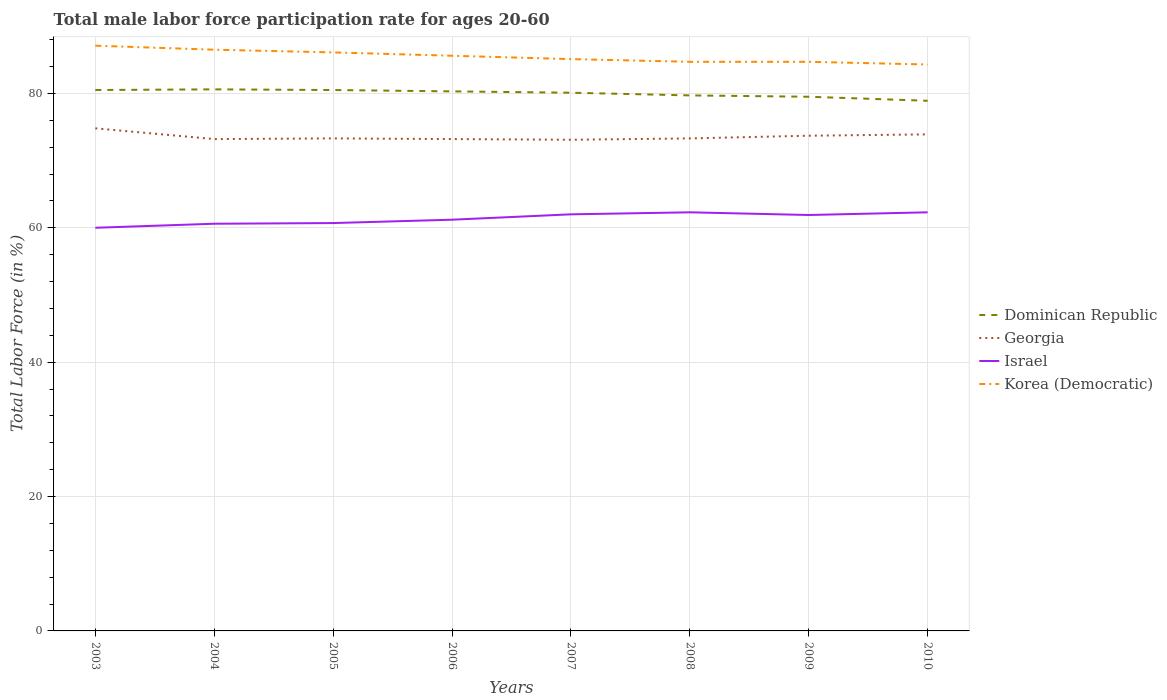Does the line corresponding to Georgia intersect with the line corresponding to Korea (Democratic)?
Offer a very short reply. No. Across all years, what is the maximum male labor force participation rate in Korea (Democratic)?
Provide a succinct answer. 84.3. In which year was the male labor force participation rate in Georgia maximum?
Keep it short and to the point. 2007. What is the difference between the highest and the second highest male labor force participation rate in Israel?
Your response must be concise. 2.3. Is the male labor force participation rate in Georgia strictly greater than the male labor force participation rate in Israel over the years?
Keep it short and to the point. No. What is the difference between two consecutive major ticks on the Y-axis?
Provide a succinct answer. 20. Does the graph contain grids?
Offer a terse response. Yes. How many legend labels are there?
Offer a terse response. 4. How are the legend labels stacked?
Make the answer very short. Vertical. What is the title of the graph?
Offer a terse response. Total male labor force participation rate for ages 20-60. Does "Northern Mariana Islands" appear as one of the legend labels in the graph?
Give a very brief answer. No. What is the label or title of the X-axis?
Offer a very short reply. Years. What is the label or title of the Y-axis?
Provide a succinct answer. Total Labor Force (in %). What is the Total Labor Force (in %) of Dominican Republic in 2003?
Ensure brevity in your answer.  80.5. What is the Total Labor Force (in %) of Georgia in 2003?
Your answer should be compact. 74.8. What is the Total Labor Force (in %) in Israel in 2003?
Offer a very short reply. 60. What is the Total Labor Force (in %) of Korea (Democratic) in 2003?
Offer a very short reply. 87.1. What is the Total Labor Force (in %) in Dominican Republic in 2004?
Ensure brevity in your answer.  80.6. What is the Total Labor Force (in %) in Georgia in 2004?
Make the answer very short. 73.2. What is the Total Labor Force (in %) in Israel in 2004?
Your answer should be very brief. 60.6. What is the Total Labor Force (in %) in Korea (Democratic) in 2004?
Keep it short and to the point. 86.5. What is the Total Labor Force (in %) of Dominican Republic in 2005?
Give a very brief answer. 80.5. What is the Total Labor Force (in %) in Georgia in 2005?
Give a very brief answer. 73.3. What is the Total Labor Force (in %) of Israel in 2005?
Provide a succinct answer. 60.7. What is the Total Labor Force (in %) of Korea (Democratic) in 2005?
Keep it short and to the point. 86.1. What is the Total Labor Force (in %) in Dominican Republic in 2006?
Keep it short and to the point. 80.3. What is the Total Labor Force (in %) in Georgia in 2006?
Your response must be concise. 73.2. What is the Total Labor Force (in %) in Israel in 2006?
Make the answer very short. 61.2. What is the Total Labor Force (in %) of Korea (Democratic) in 2006?
Your answer should be compact. 85.6. What is the Total Labor Force (in %) in Dominican Republic in 2007?
Keep it short and to the point. 80.1. What is the Total Labor Force (in %) of Georgia in 2007?
Offer a very short reply. 73.1. What is the Total Labor Force (in %) of Israel in 2007?
Your answer should be compact. 62. What is the Total Labor Force (in %) of Korea (Democratic) in 2007?
Your answer should be compact. 85.1. What is the Total Labor Force (in %) of Dominican Republic in 2008?
Make the answer very short. 79.7. What is the Total Labor Force (in %) of Georgia in 2008?
Offer a very short reply. 73.3. What is the Total Labor Force (in %) in Israel in 2008?
Your answer should be very brief. 62.3. What is the Total Labor Force (in %) of Korea (Democratic) in 2008?
Ensure brevity in your answer.  84.7. What is the Total Labor Force (in %) of Dominican Republic in 2009?
Your answer should be compact. 79.5. What is the Total Labor Force (in %) of Georgia in 2009?
Your answer should be compact. 73.7. What is the Total Labor Force (in %) in Israel in 2009?
Your answer should be compact. 61.9. What is the Total Labor Force (in %) of Korea (Democratic) in 2009?
Your answer should be very brief. 84.7. What is the Total Labor Force (in %) in Dominican Republic in 2010?
Keep it short and to the point. 78.9. What is the Total Labor Force (in %) of Georgia in 2010?
Offer a terse response. 73.9. What is the Total Labor Force (in %) in Israel in 2010?
Provide a short and direct response. 62.3. What is the Total Labor Force (in %) of Korea (Democratic) in 2010?
Provide a short and direct response. 84.3. Across all years, what is the maximum Total Labor Force (in %) of Dominican Republic?
Make the answer very short. 80.6. Across all years, what is the maximum Total Labor Force (in %) in Georgia?
Offer a very short reply. 74.8. Across all years, what is the maximum Total Labor Force (in %) of Israel?
Your response must be concise. 62.3. Across all years, what is the maximum Total Labor Force (in %) of Korea (Democratic)?
Ensure brevity in your answer.  87.1. Across all years, what is the minimum Total Labor Force (in %) of Dominican Republic?
Ensure brevity in your answer.  78.9. Across all years, what is the minimum Total Labor Force (in %) of Georgia?
Give a very brief answer. 73.1. Across all years, what is the minimum Total Labor Force (in %) in Korea (Democratic)?
Your response must be concise. 84.3. What is the total Total Labor Force (in %) of Dominican Republic in the graph?
Provide a short and direct response. 640.1. What is the total Total Labor Force (in %) of Georgia in the graph?
Give a very brief answer. 588.5. What is the total Total Labor Force (in %) in Israel in the graph?
Make the answer very short. 491. What is the total Total Labor Force (in %) in Korea (Democratic) in the graph?
Your answer should be compact. 684.1. What is the difference between the Total Labor Force (in %) of Dominican Republic in 2003 and that in 2005?
Your answer should be very brief. 0. What is the difference between the Total Labor Force (in %) of Georgia in 2003 and that in 2006?
Offer a terse response. 1.6. What is the difference between the Total Labor Force (in %) in Israel in 2003 and that in 2006?
Offer a terse response. -1.2. What is the difference between the Total Labor Force (in %) of Korea (Democratic) in 2003 and that in 2006?
Ensure brevity in your answer.  1.5. What is the difference between the Total Labor Force (in %) of Dominican Republic in 2003 and that in 2007?
Give a very brief answer. 0.4. What is the difference between the Total Labor Force (in %) in Israel in 2003 and that in 2007?
Your answer should be very brief. -2. What is the difference between the Total Labor Force (in %) of Dominican Republic in 2003 and that in 2008?
Keep it short and to the point. 0.8. What is the difference between the Total Labor Force (in %) of Korea (Democratic) in 2003 and that in 2008?
Offer a very short reply. 2.4. What is the difference between the Total Labor Force (in %) of Dominican Republic in 2003 and that in 2009?
Ensure brevity in your answer.  1. What is the difference between the Total Labor Force (in %) in Dominican Republic in 2003 and that in 2010?
Offer a terse response. 1.6. What is the difference between the Total Labor Force (in %) in Georgia in 2003 and that in 2010?
Your answer should be compact. 0.9. What is the difference between the Total Labor Force (in %) of Israel in 2003 and that in 2010?
Provide a succinct answer. -2.3. What is the difference between the Total Labor Force (in %) in Dominican Republic in 2004 and that in 2005?
Keep it short and to the point. 0.1. What is the difference between the Total Labor Force (in %) in Georgia in 2004 and that in 2005?
Make the answer very short. -0.1. What is the difference between the Total Labor Force (in %) in Dominican Republic in 2004 and that in 2006?
Your answer should be compact. 0.3. What is the difference between the Total Labor Force (in %) in Korea (Democratic) in 2004 and that in 2008?
Give a very brief answer. 1.8. What is the difference between the Total Labor Force (in %) of Georgia in 2004 and that in 2009?
Your response must be concise. -0.5. What is the difference between the Total Labor Force (in %) of Israel in 2004 and that in 2009?
Your answer should be compact. -1.3. What is the difference between the Total Labor Force (in %) in Korea (Democratic) in 2004 and that in 2009?
Give a very brief answer. 1.8. What is the difference between the Total Labor Force (in %) in Dominican Republic in 2004 and that in 2010?
Ensure brevity in your answer.  1.7. What is the difference between the Total Labor Force (in %) of Korea (Democratic) in 2004 and that in 2010?
Ensure brevity in your answer.  2.2. What is the difference between the Total Labor Force (in %) of Dominican Republic in 2005 and that in 2006?
Your answer should be compact. 0.2. What is the difference between the Total Labor Force (in %) in Georgia in 2005 and that in 2006?
Provide a succinct answer. 0.1. What is the difference between the Total Labor Force (in %) of Israel in 2005 and that in 2006?
Provide a succinct answer. -0.5. What is the difference between the Total Labor Force (in %) in Korea (Democratic) in 2005 and that in 2006?
Provide a short and direct response. 0.5. What is the difference between the Total Labor Force (in %) of Dominican Republic in 2005 and that in 2007?
Your answer should be compact. 0.4. What is the difference between the Total Labor Force (in %) of Georgia in 2005 and that in 2007?
Your answer should be compact. 0.2. What is the difference between the Total Labor Force (in %) of Georgia in 2005 and that in 2008?
Provide a short and direct response. 0. What is the difference between the Total Labor Force (in %) of Korea (Democratic) in 2005 and that in 2008?
Provide a short and direct response. 1.4. What is the difference between the Total Labor Force (in %) in Dominican Republic in 2005 and that in 2009?
Ensure brevity in your answer.  1. What is the difference between the Total Labor Force (in %) in Korea (Democratic) in 2005 and that in 2009?
Keep it short and to the point. 1.4. What is the difference between the Total Labor Force (in %) in Dominican Republic in 2005 and that in 2010?
Provide a short and direct response. 1.6. What is the difference between the Total Labor Force (in %) of Georgia in 2006 and that in 2007?
Give a very brief answer. 0.1. What is the difference between the Total Labor Force (in %) in Israel in 2006 and that in 2007?
Your answer should be very brief. -0.8. What is the difference between the Total Labor Force (in %) of Korea (Democratic) in 2006 and that in 2008?
Give a very brief answer. 0.9. What is the difference between the Total Labor Force (in %) of Dominican Republic in 2006 and that in 2009?
Ensure brevity in your answer.  0.8. What is the difference between the Total Labor Force (in %) in Israel in 2006 and that in 2009?
Your answer should be compact. -0.7. What is the difference between the Total Labor Force (in %) of Korea (Democratic) in 2006 and that in 2009?
Offer a terse response. 0.9. What is the difference between the Total Labor Force (in %) of Dominican Republic in 2006 and that in 2010?
Make the answer very short. 1.4. What is the difference between the Total Labor Force (in %) in Israel in 2006 and that in 2010?
Your response must be concise. -1.1. What is the difference between the Total Labor Force (in %) of Korea (Democratic) in 2006 and that in 2010?
Your response must be concise. 1.3. What is the difference between the Total Labor Force (in %) of Dominican Republic in 2007 and that in 2008?
Offer a very short reply. 0.4. What is the difference between the Total Labor Force (in %) of Georgia in 2007 and that in 2008?
Your response must be concise. -0.2. What is the difference between the Total Labor Force (in %) in Israel in 2007 and that in 2008?
Give a very brief answer. -0.3. What is the difference between the Total Labor Force (in %) of Israel in 2007 and that in 2009?
Your response must be concise. 0.1. What is the difference between the Total Labor Force (in %) in Korea (Democratic) in 2007 and that in 2009?
Your response must be concise. 0.4. What is the difference between the Total Labor Force (in %) in Dominican Republic in 2007 and that in 2010?
Offer a very short reply. 1.2. What is the difference between the Total Labor Force (in %) in Georgia in 2007 and that in 2010?
Your answer should be very brief. -0.8. What is the difference between the Total Labor Force (in %) of Dominican Republic in 2008 and that in 2009?
Ensure brevity in your answer.  0.2. What is the difference between the Total Labor Force (in %) of Israel in 2008 and that in 2009?
Your answer should be very brief. 0.4. What is the difference between the Total Labor Force (in %) of Korea (Democratic) in 2008 and that in 2009?
Your answer should be compact. 0. What is the difference between the Total Labor Force (in %) of Israel in 2008 and that in 2010?
Your answer should be very brief. 0. What is the difference between the Total Labor Force (in %) in Israel in 2009 and that in 2010?
Give a very brief answer. -0.4. What is the difference between the Total Labor Force (in %) in Korea (Democratic) in 2009 and that in 2010?
Your answer should be very brief. 0.4. What is the difference between the Total Labor Force (in %) in Georgia in 2003 and the Total Labor Force (in %) in Israel in 2004?
Keep it short and to the point. 14.2. What is the difference between the Total Labor Force (in %) in Georgia in 2003 and the Total Labor Force (in %) in Korea (Democratic) in 2004?
Give a very brief answer. -11.7. What is the difference between the Total Labor Force (in %) of Israel in 2003 and the Total Labor Force (in %) of Korea (Democratic) in 2004?
Your answer should be very brief. -26.5. What is the difference between the Total Labor Force (in %) of Dominican Republic in 2003 and the Total Labor Force (in %) of Georgia in 2005?
Ensure brevity in your answer.  7.2. What is the difference between the Total Labor Force (in %) in Dominican Republic in 2003 and the Total Labor Force (in %) in Israel in 2005?
Keep it short and to the point. 19.8. What is the difference between the Total Labor Force (in %) of Dominican Republic in 2003 and the Total Labor Force (in %) of Korea (Democratic) in 2005?
Ensure brevity in your answer.  -5.6. What is the difference between the Total Labor Force (in %) in Georgia in 2003 and the Total Labor Force (in %) in Korea (Democratic) in 2005?
Ensure brevity in your answer.  -11.3. What is the difference between the Total Labor Force (in %) of Israel in 2003 and the Total Labor Force (in %) of Korea (Democratic) in 2005?
Provide a succinct answer. -26.1. What is the difference between the Total Labor Force (in %) of Dominican Republic in 2003 and the Total Labor Force (in %) of Georgia in 2006?
Keep it short and to the point. 7.3. What is the difference between the Total Labor Force (in %) of Dominican Republic in 2003 and the Total Labor Force (in %) of Israel in 2006?
Offer a very short reply. 19.3. What is the difference between the Total Labor Force (in %) in Israel in 2003 and the Total Labor Force (in %) in Korea (Democratic) in 2006?
Your response must be concise. -25.6. What is the difference between the Total Labor Force (in %) of Dominican Republic in 2003 and the Total Labor Force (in %) of Israel in 2007?
Offer a very short reply. 18.5. What is the difference between the Total Labor Force (in %) in Georgia in 2003 and the Total Labor Force (in %) in Israel in 2007?
Your response must be concise. 12.8. What is the difference between the Total Labor Force (in %) in Georgia in 2003 and the Total Labor Force (in %) in Korea (Democratic) in 2007?
Ensure brevity in your answer.  -10.3. What is the difference between the Total Labor Force (in %) in Israel in 2003 and the Total Labor Force (in %) in Korea (Democratic) in 2007?
Ensure brevity in your answer.  -25.1. What is the difference between the Total Labor Force (in %) in Dominican Republic in 2003 and the Total Labor Force (in %) in Israel in 2008?
Your answer should be very brief. 18.2. What is the difference between the Total Labor Force (in %) in Dominican Republic in 2003 and the Total Labor Force (in %) in Korea (Democratic) in 2008?
Give a very brief answer. -4.2. What is the difference between the Total Labor Force (in %) in Israel in 2003 and the Total Labor Force (in %) in Korea (Democratic) in 2008?
Your response must be concise. -24.7. What is the difference between the Total Labor Force (in %) in Dominican Republic in 2003 and the Total Labor Force (in %) in Korea (Democratic) in 2009?
Offer a terse response. -4.2. What is the difference between the Total Labor Force (in %) of Israel in 2003 and the Total Labor Force (in %) of Korea (Democratic) in 2009?
Provide a succinct answer. -24.7. What is the difference between the Total Labor Force (in %) of Dominican Republic in 2003 and the Total Labor Force (in %) of Israel in 2010?
Provide a succinct answer. 18.2. What is the difference between the Total Labor Force (in %) of Dominican Republic in 2003 and the Total Labor Force (in %) of Korea (Democratic) in 2010?
Provide a short and direct response. -3.8. What is the difference between the Total Labor Force (in %) of Georgia in 2003 and the Total Labor Force (in %) of Israel in 2010?
Keep it short and to the point. 12.5. What is the difference between the Total Labor Force (in %) of Georgia in 2003 and the Total Labor Force (in %) of Korea (Democratic) in 2010?
Ensure brevity in your answer.  -9.5. What is the difference between the Total Labor Force (in %) in Israel in 2003 and the Total Labor Force (in %) in Korea (Democratic) in 2010?
Keep it short and to the point. -24.3. What is the difference between the Total Labor Force (in %) in Georgia in 2004 and the Total Labor Force (in %) in Israel in 2005?
Make the answer very short. 12.5. What is the difference between the Total Labor Force (in %) of Israel in 2004 and the Total Labor Force (in %) of Korea (Democratic) in 2005?
Your answer should be compact. -25.5. What is the difference between the Total Labor Force (in %) in Dominican Republic in 2004 and the Total Labor Force (in %) in Israel in 2006?
Your answer should be very brief. 19.4. What is the difference between the Total Labor Force (in %) in Dominican Republic in 2004 and the Total Labor Force (in %) in Korea (Democratic) in 2006?
Provide a short and direct response. -5. What is the difference between the Total Labor Force (in %) of Georgia in 2004 and the Total Labor Force (in %) of Israel in 2006?
Keep it short and to the point. 12. What is the difference between the Total Labor Force (in %) in Georgia in 2004 and the Total Labor Force (in %) in Korea (Democratic) in 2007?
Provide a short and direct response. -11.9. What is the difference between the Total Labor Force (in %) in Israel in 2004 and the Total Labor Force (in %) in Korea (Democratic) in 2007?
Your answer should be compact. -24.5. What is the difference between the Total Labor Force (in %) in Dominican Republic in 2004 and the Total Labor Force (in %) in Israel in 2008?
Provide a succinct answer. 18.3. What is the difference between the Total Labor Force (in %) of Dominican Republic in 2004 and the Total Labor Force (in %) of Korea (Democratic) in 2008?
Provide a short and direct response. -4.1. What is the difference between the Total Labor Force (in %) of Georgia in 2004 and the Total Labor Force (in %) of Israel in 2008?
Offer a very short reply. 10.9. What is the difference between the Total Labor Force (in %) of Georgia in 2004 and the Total Labor Force (in %) of Korea (Democratic) in 2008?
Your answer should be very brief. -11.5. What is the difference between the Total Labor Force (in %) of Israel in 2004 and the Total Labor Force (in %) of Korea (Democratic) in 2008?
Your answer should be compact. -24.1. What is the difference between the Total Labor Force (in %) of Georgia in 2004 and the Total Labor Force (in %) of Korea (Democratic) in 2009?
Offer a very short reply. -11.5. What is the difference between the Total Labor Force (in %) in Israel in 2004 and the Total Labor Force (in %) in Korea (Democratic) in 2009?
Provide a short and direct response. -24.1. What is the difference between the Total Labor Force (in %) of Dominican Republic in 2004 and the Total Labor Force (in %) of Israel in 2010?
Keep it short and to the point. 18.3. What is the difference between the Total Labor Force (in %) of Dominican Republic in 2004 and the Total Labor Force (in %) of Korea (Democratic) in 2010?
Provide a short and direct response. -3.7. What is the difference between the Total Labor Force (in %) of Georgia in 2004 and the Total Labor Force (in %) of Korea (Democratic) in 2010?
Your response must be concise. -11.1. What is the difference between the Total Labor Force (in %) of Israel in 2004 and the Total Labor Force (in %) of Korea (Democratic) in 2010?
Offer a terse response. -23.7. What is the difference between the Total Labor Force (in %) in Dominican Republic in 2005 and the Total Labor Force (in %) in Georgia in 2006?
Ensure brevity in your answer.  7.3. What is the difference between the Total Labor Force (in %) in Dominican Republic in 2005 and the Total Labor Force (in %) in Israel in 2006?
Provide a short and direct response. 19.3. What is the difference between the Total Labor Force (in %) of Dominican Republic in 2005 and the Total Labor Force (in %) of Korea (Democratic) in 2006?
Your answer should be very brief. -5.1. What is the difference between the Total Labor Force (in %) of Georgia in 2005 and the Total Labor Force (in %) of Israel in 2006?
Ensure brevity in your answer.  12.1. What is the difference between the Total Labor Force (in %) of Georgia in 2005 and the Total Labor Force (in %) of Korea (Democratic) in 2006?
Your answer should be compact. -12.3. What is the difference between the Total Labor Force (in %) in Israel in 2005 and the Total Labor Force (in %) in Korea (Democratic) in 2006?
Give a very brief answer. -24.9. What is the difference between the Total Labor Force (in %) of Dominican Republic in 2005 and the Total Labor Force (in %) of Israel in 2007?
Your response must be concise. 18.5. What is the difference between the Total Labor Force (in %) of Dominican Republic in 2005 and the Total Labor Force (in %) of Korea (Democratic) in 2007?
Ensure brevity in your answer.  -4.6. What is the difference between the Total Labor Force (in %) of Israel in 2005 and the Total Labor Force (in %) of Korea (Democratic) in 2007?
Provide a succinct answer. -24.4. What is the difference between the Total Labor Force (in %) in Dominican Republic in 2005 and the Total Labor Force (in %) in Georgia in 2008?
Ensure brevity in your answer.  7.2. What is the difference between the Total Labor Force (in %) in Dominican Republic in 2005 and the Total Labor Force (in %) in Korea (Democratic) in 2008?
Provide a short and direct response. -4.2. What is the difference between the Total Labor Force (in %) in Georgia in 2005 and the Total Labor Force (in %) in Korea (Democratic) in 2008?
Provide a succinct answer. -11.4. What is the difference between the Total Labor Force (in %) of Dominican Republic in 2005 and the Total Labor Force (in %) of Georgia in 2009?
Offer a very short reply. 6.8. What is the difference between the Total Labor Force (in %) in Dominican Republic in 2005 and the Total Labor Force (in %) in Korea (Democratic) in 2009?
Give a very brief answer. -4.2. What is the difference between the Total Labor Force (in %) of Georgia in 2005 and the Total Labor Force (in %) of Israel in 2009?
Keep it short and to the point. 11.4. What is the difference between the Total Labor Force (in %) in Israel in 2005 and the Total Labor Force (in %) in Korea (Democratic) in 2009?
Provide a succinct answer. -24. What is the difference between the Total Labor Force (in %) of Dominican Republic in 2005 and the Total Labor Force (in %) of Georgia in 2010?
Your response must be concise. 6.6. What is the difference between the Total Labor Force (in %) of Georgia in 2005 and the Total Labor Force (in %) of Israel in 2010?
Your response must be concise. 11. What is the difference between the Total Labor Force (in %) of Georgia in 2005 and the Total Labor Force (in %) of Korea (Democratic) in 2010?
Your response must be concise. -11. What is the difference between the Total Labor Force (in %) of Israel in 2005 and the Total Labor Force (in %) of Korea (Democratic) in 2010?
Provide a short and direct response. -23.6. What is the difference between the Total Labor Force (in %) of Dominican Republic in 2006 and the Total Labor Force (in %) of Georgia in 2007?
Your answer should be compact. 7.2. What is the difference between the Total Labor Force (in %) in Dominican Republic in 2006 and the Total Labor Force (in %) in Israel in 2007?
Ensure brevity in your answer.  18.3. What is the difference between the Total Labor Force (in %) of Dominican Republic in 2006 and the Total Labor Force (in %) of Korea (Democratic) in 2007?
Provide a short and direct response. -4.8. What is the difference between the Total Labor Force (in %) of Israel in 2006 and the Total Labor Force (in %) of Korea (Democratic) in 2007?
Your answer should be compact. -23.9. What is the difference between the Total Labor Force (in %) in Georgia in 2006 and the Total Labor Force (in %) in Israel in 2008?
Give a very brief answer. 10.9. What is the difference between the Total Labor Force (in %) of Georgia in 2006 and the Total Labor Force (in %) of Korea (Democratic) in 2008?
Give a very brief answer. -11.5. What is the difference between the Total Labor Force (in %) in Israel in 2006 and the Total Labor Force (in %) in Korea (Democratic) in 2008?
Your response must be concise. -23.5. What is the difference between the Total Labor Force (in %) in Georgia in 2006 and the Total Labor Force (in %) in Israel in 2009?
Ensure brevity in your answer.  11.3. What is the difference between the Total Labor Force (in %) in Georgia in 2006 and the Total Labor Force (in %) in Korea (Democratic) in 2009?
Offer a very short reply. -11.5. What is the difference between the Total Labor Force (in %) in Israel in 2006 and the Total Labor Force (in %) in Korea (Democratic) in 2009?
Offer a terse response. -23.5. What is the difference between the Total Labor Force (in %) in Dominican Republic in 2006 and the Total Labor Force (in %) in Israel in 2010?
Offer a very short reply. 18. What is the difference between the Total Labor Force (in %) of Georgia in 2006 and the Total Labor Force (in %) of Israel in 2010?
Provide a short and direct response. 10.9. What is the difference between the Total Labor Force (in %) in Israel in 2006 and the Total Labor Force (in %) in Korea (Democratic) in 2010?
Give a very brief answer. -23.1. What is the difference between the Total Labor Force (in %) of Dominican Republic in 2007 and the Total Labor Force (in %) of Georgia in 2008?
Keep it short and to the point. 6.8. What is the difference between the Total Labor Force (in %) of Dominican Republic in 2007 and the Total Labor Force (in %) of Israel in 2008?
Ensure brevity in your answer.  17.8. What is the difference between the Total Labor Force (in %) in Dominican Republic in 2007 and the Total Labor Force (in %) in Korea (Democratic) in 2008?
Your response must be concise. -4.6. What is the difference between the Total Labor Force (in %) of Georgia in 2007 and the Total Labor Force (in %) of Korea (Democratic) in 2008?
Offer a terse response. -11.6. What is the difference between the Total Labor Force (in %) of Israel in 2007 and the Total Labor Force (in %) of Korea (Democratic) in 2008?
Provide a short and direct response. -22.7. What is the difference between the Total Labor Force (in %) of Dominican Republic in 2007 and the Total Labor Force (in %) of Israel in 2009?
Your answer should be very brief. 18.2. What is the difference between the Total Labor Force (in %) of Dominican Republic in 2007 and the Total Labor Force (in %) of Korea (Democratic) in 2009?
Your answer should be very brief. -4.6. What is the difference between the Total Labor Force (in %) in Georgia in 2007 and the Total Labor Force (in %) in Korea (Democratic) in 2009?
Your response must be concise. -11.6. What is the difference between the Total Labor Force (in %) in Israel in 2007 and the Total Labor Force (in %) in Korea (Democratic) in 2009?
Give a very brief answer. -22.7. What is the difference between the Total Labor Force (in %) of Dominican Republic in 2007 and the Total Labor Force (in %) of Georgia in 2010?
Keep it short and to the point. 6.2. What is the difference between the Total Labor Force (in %) of Dominican Republic in 2007 and the Total Labor Force (in %) of Korea (Democratic) in 2010?
Provide a short and direct response. -4.2. What is the difference between the Total Labor Force (in %) of Israel in 2007 and the Total Labor Force (in %) of Korea (Democratic) in 2010?
Give a very brief answer. -22.3. What is the difference between the Total Labor Force (in %) of Dominican Republic in 2008 and the Total Labor Force (in %) of Georgia in 2009?
Offer a terse response. 6. What is the difference between the Total Labor Force (in %) of Dominican Republic in 2008 and the Total Labor Force (in %) of Israel in 2009?
Provide a short and direct response. 17.8. What is the difference between the Total Labor Force (in %) of Dominican Republic in 2008 and the Total Labor Force (in %) of Korea (Democratic) in 2009?
Offer a very short reply. -5. What is the difference between the Total Labor Force (in %) in Israel in 2008 and the Total Labor Force (in %) in Korea (Democratic) in 2009?
Ensure brevity in your answer.  -22.4. What is the difference between the Total Labor Force (in %) of Dominican Republic in 2008 and the Total Labor Force (in %) of Georgia in 2010?
Your answer should be very brief. 5.8. What is the difference between the Total Labor Force (in %) in Georgia in 2008 and the Total Labor Force (in %) in Israel in 2010?
Offer a terse response. 11. What is the difference between the Total Labor Force (in %) in Israel in 2008 and the Total Labor Force (in %) in Korea (Democratic) in 2010?
Offer a terse response. -22. What is the difference between the Total Labor Force (in %) of Dominican Republic in 2009 and the Total Labor Force (in %) of Georgia in 2010?
Your answer should be compact. 5.6. What is the difference between the Total Labor Force (in %) in Georgia in 2009 and the Total Labor Force (in %) in Israel in 2010?
Your answer should be very brief. 11.4. What is the difference between the Total Labor Force (in %) in Israel in 2009 and the Total Labor Force (in %) in Korea (Democratic) in 2010?
Ensure brevity in your answer.  -22.4. What is the average Total Labor Force (in %) of Dominican Republic per year?
Your answer should be compact. 80.01. What is the average Total Labor Force (in %) of Georgia per year?
Make the answer very short. 73.56. What is the average Total Labor Force (in %) in Israel per year?
Offer a terse response. 61.38. What is the average Total Labor Force (in %) in Korea (Democratic) per year?
Ensure brevity in your answer.  85.51. In the year 2003, what is the difference between the Total Labor Force (in %) of Dominican Republic and Total Labor Force (in %) of Georgia?
Ensure brevity in your answer.  5.7. In the year 2003, what is the difference between the Total Labor Force (in %) in Dominican Republic and Total Labor Force (in %) in Israel?
Keep it short and to the point. 20.5. In the year 2003, what is the difference between the Total Labor Force (in %) of Dominican Republic and Total Labor Force (in %) of Korea (Democratic)?
Your answer should be compact. -6.6. In the year 2003, what is the difference between the Total Labor Force (in %) of Israel and Total Labor Force (in %) of Korea (Democratic)?
Your answer should be very brief. -27.1. In the year 2004, what is the difference between the Total Labor Force (in %) of Dominican Republic and Total Labor Force (in %) of Israel?
Give a very brief answer. 20. In the year 2004, what is the difference between the Total Labor Force (in %) in Dominican Republic and Total Labor Force (in %) in Korea (Democratic)?
Keep it short and to the point. -5.9. In the year 2004, what is the difference between the Total Labor Force (in %) in Israel and Total Labor Force (in %) in Korea (Democratic)?
Provide a succinct answer. -25.9. In the year 2005, what is the difference between the Total Labor Force (in %) in Dominican Republic and Total Labor Force (in %) in Israel?
Ensure brevity in your answer.  19.8. In the year 2005, what is the difference between the Total Labor Force (in %) in Israel and Total Labor Force (in %) in Korea (Democratic)?
Make the answer very short. -25.4. In the year 2006, what is the difference between the Total Labor Force (in %) of Dominican Republic and Total Labor Force (in %) of Georgia?
Ensure brevity in your answer.  7.1. In the year 2006, what is the difference between the Total Labor Force (in %) of Dominican Republic and Total Labor Force (in %) of Israel?
Keep it short and to the point. 19.1. In the year 2006, what is the difference between the Total Labor Force (in %) of Israel and Total Labor Force (in %) of Korea (Democratic)?
Your response must be concise. -24.4. In the year 2007, what is the difference between the Total Labor Force (in %) of Dominican Republic and Total Labor Force (in %) of Israel?
Provide a succinct answer. 18.1. In the year 2007, what is the difference between the Total Labor Force (in %) of Georgia and Total Labor Force (in %) of Israel?
Ensure brevity in your answer.  11.1. In the year 2007, what is the difference between the Total Labor Force (in %) of Israel and Total Labor Force (in %) of Korea (Democratic)?
Make the answer very short. -23.1. In the year 2008, what is the difference between the Total Labor Force (in %) in Dominican Republic and Total Labor Force (in %) in Israel?
Your response must be concise. 17.4. In the year 2008, what is the difference between the Total Labor Force (in %) of Dominican Republic and Total Labor Force (in %) of Korea (Democratic)?
Your response must be concise. -5. In the year 2008, what is the difference between the Total Labor Force (in %) of Georgia and Total Labor Force (in %) of Israel?
Make the answer very short. 11. In the year 2008, what is the difference between the Total Labor Force (in %) of Georgia and Total Labor Force (in %) of Korea (Democratic)?
Provide a short and direct response. -11.4. In the year 2008, what is the difference between the Total Labor Force (in %) of Israel and Total Labor Force (in %) of Korea (Democratic)?
Ensure brevity in your answer.  -22.4. In the year 2009, what is the difference between the Total Labor Force (in %) in Dominican Republic and Total Labor Force (in %) in Georgia?
Your response must be concise. 5.8. In the year 2009, what is the difference between the Total Labor Force (in %) of Dominican Republic and Total Labor Force (in %) of Israel?
Provide a short and direct response. 17.6. In the year 2009, what is the difference between the Total Labor Force (in %) in Dominican Republic and Total Labor Force (in %) in Korea (Democratic)?
Provide a short and direct response. -5.2. In the year 2009, what is the difference between the Total Labor Force (in %) of Georgia and Total Labor Force (in %) of Israel?
Offer a terse response. 11.8. In the year 2009, what is the difference between the Total Labor Force (in %) of Georgia and Total Labor Force (in %) of Korea (Democratic)?
Keep it short and to the point. -11. In the year 2009, what is the difference between the Total Labor Force (in %) of Israel and Total Labor Force (in %) of Korea (Democratic)?
Offer a terse response. -22.8. In the year 2010, what is the difference between the Total Labor Force (in %) of Dominican Republic and Total Labor Force (in %) of Israel?
Ensure brevity in your answer.  16.6. What is the ratio of the Total Labor Force (in %) in Dominican Republic in 2003 to that in 2004?
Make the answer very short. 1. What is the ratio of the Total Labor Force (in %) of Georgia in 2003 to that in 2004?
Give a very brief answer. 1.02. What is the ratio of the Total Labor Force (in %) of Georgia in 2003 to that in 2005?
Keep it short and to the point. 1.02. What is the ratio of the Total Labor Force (in %) in Israel in 2003 to that in 2005?
Your response must be concise. 0.99. What is the ratio of the Total Labor Force (in %) in Korea (Democratic) in 2003 to that in 2005?
Ensure brevity in your answer.  1.01. What is the ratio of the Total Labor Force (in %) in Georgia in 2003 to that in 2006?
Offer a terse response. 1.02. What is the ratio of the Total Labor Force (in %) in Israel in 2003 to that in 2006?
Offer a very short reply. 0.98. What is the ratio of the Total Labor Force (in %) in Korea (Democratic) in 2003 to that in 2006?
Your response must be concise. 1.02. What is the ratio of the Total Labor Force (in %) of Georgia in 2003 to that in 2007?
Offer a very short reply. 1.02. What is the ratio of the Total Labor Force (in %) in Korea (Democratic) in 2003 to that in 2007?
Provide a short and direct response. 1.02. What is the ratio of the Total Labor Force (in %) of Dominican Republic in 2003 to that in 2008?
Your answer should be compact. 1.01. What is the ratio of the Total Labor Force (in %) in Georgia in 2003 to that in 2008?
Keep it short and to the point. 1.02. What is the ratio of the Total Labor Force (in %) of Israel in 2003 to that in 2008?
Your response must be concise. 0.96. What is the ratio of the Total Labor Force (in %) in Korea (Democratic) in 2003 to that in 2008?
Your answer should be very brief. 1.03. What is the ratio of the Total Labor Force (in %) of Dominican Republic in 2003 to that in 2009?
Offer a very short reply. 1.01. What is the ratio of the Total Labor Force (in %) of Georgia in 2003 to that in 2009?
Provide a short and direct response. 1.01. What is the ratio of the Total Labor Force (in %) in Israel in 2003 to that in 2009?
Keep it short and to the point. 0.97. What is the ratio of the Total Labor Force (in %) of Korea (Democratic) in 2003 to that in 2009?
Your answer should be very brief. 1.03. What is the ratio of the Total Labor Force (in %) of Dominican Republic in 2003 to that in 2010?
Offer a very short reply. 1.02. What is the ratio of the Total Labor Force (in %) of Georgia in 2003 to that in 2010?
Ensure brevity in your answer.  1.01. What is the ratio of the Total Labor Force (in %) of Israel in 2003 to that in 2010?
Give a very brief answer. 0.96. What is the ratio of the Total Labor Force (in %) of Korea (Democratic) in 2003 to that in 2010?
Provide a succinct answer. 1.03. What is the ratio of the Total Labor Force (in %) of Israel in 2004 to that in 2005?
Keep it short and to the point. 1. What is the ratio of the Total Labor Force (in %) of Georgia in 2004 to that in 2006?
Make the answer very short. 1. What is the ratio of the Total Labor Force (in %) of Israel in 2004 to that in 2006?
Your answer should be compact. 0.99. What is the ratio of the Total Labor Force (in %) of Korea (Democratic) in 2004 to that in 2006?
Provide a short and direct response. 1.01. What is the ratio of the Total Labor Force (in %) of Dominican Republic in 2004 to that in 2007?
Your answer should be compact. 1.01. What is the ratio of the Total Labor Force (in %) of Israel in 2004 to that in 2007?
Ensure brevity in your answer.  0.98. What is the ratio of the Total Labor Force (in %) of Korea (Democratic) in 2004 to that in 2007?
Make the answer very short. 1.02. What is the ratio of the Total Labor Force (in %) of Dominican Republic in 2004 to that in 2008?
Provide a short and direct response. 1.01. What is the ratio of the Total Labor Force (in %) of Israel in 2004 to that in 2008?
Offer a terse response. 0.97. What is the ratio of the Total Labor Force (in %) of Korea (Democratic) in 2004 to that in 2008?
Your response must be concise. 1.02. What is the ratio of the Total Labor Force (in %) of Dominican Republic in 2004 to that in 2009?
Provide a succinct answer. 1.01. What is the ratio of the Total Labor Force (in %) of Georgia in 2004 to that in 2009?
Your answer should be compact. 0.99. What is the ratio of the Total Labor Force (in %) in Israel in 2004 to that in 2009?
Your answer should be compact. 0.98. What is the ratio of the Total Labor Force (in %) in Korea (Democratic) in 2004 to that in 2009?
Keep it short and to the point. 1.02. What is the ratio of the Total Labor Force (in %) in Dominican Republic in 2004 to that in 2010?
Your answer should be compact. 1.02. What is the ratio of the Total Labor Force (in %) of Georgia in 2004 to that in 2010?
Your answer should be very brief. 0.99. What is the ratio of the Total Labor Force (in %) of Israel in 2004 to that in 2010?
Your response must be concise. 0.97. What is the ratio of the Total Labor Force (in %) of Korea (Democratic) in 2004 to that in 2010?
Ensure brevity in your answer.  1.03. What is the ratio of the Total Labor Force (in %) in Korea (Democratic) in 2005 to that in 2007?
Provide a short and direct response. 1.01. What is the ratio of the Total Labor Force (in %) in Dominican Republic in 2005 to that in 2008?
Provide a succinct answer. 1.01. What is the ratio of the Total Labor Force (in %) in Israel in 2005 to that in 2008?
Give a very brief answer. 0.97. What is the ratio of the Total Labor Force (in %) in Korea (Democratic) in 2005 to that in 2008?
Make the answer very short. 1.02. What is the ratio of the Total Labor Force (in %) in Dominican Republic in 2005 to that in 2009?
Your answer should be compact. 1.01. What is the ratio of the Total Labor Force (in %) of Israel in 2005 to that in 2009?
Your response must be concise. 0.98. What is the ratio of the Total Labor Force (in %) of Korea (Democratic) in 2005 to that in 2009?
Offer a terse response. 1.02. What is the ratio of the Total Labor Force (in %) of Dominican Republic in 2005 to that in 2010?
Provide a succinct answer. 1.02. What is the ratio of the Total Labor Force (in %) of Israel in 2005 to that in 2010?
Your response must be concise. 0.97. What is the ratio of the Total Labor Force (in %) in Korea (Democratic) in 2005 to that in 2010?
Provide a succinct answer. 1.02. What is the ratio of the Total Labor Force (in %) of Dominican Republic in 2006 to that in 2007?
Give a very brief answer. 1. What is the ratio of the Total Labor Force (in %) in Israel in 2006 to that in 2007?
Offer a terse response. 0.99. What is the ratio of the Total Labor Force (in %) of Korea (Democratic) in 2006 to that in 2007?
Your answer should be compact. 1.01. What is the ratio of the Total Labor Force (in %) in Dominican Republic in 2006 to that in 2008?
Your answer should be compact. 1.01. What is the ratio of the Total Labor Force (in %) of Israel in 2006 to that in 2008?
Your answer should be very brief. 0.98. What is the ratio of the Total Labor Force (in %) of Korea (Democratic) in 2006 to that in 2008?
Provide a short and direct response. 1.01. What is the ratio of the Total Labor Force (in %) of Dominican Republic in 2006 to that in 2009?
Keep it short and to the point. 1.01. What is the ratio of the Total Labor Force (in %) in Israel in 2006 to that in 2009?
Make the answer very short. 0.99. What is the ratio of the Total Labor Force (in %) of Korea (Democratic) in 2006 to that in 2009?
Make the answer very short. 1.01. What is the ratio of the Total Labor Force (in %) in Dominican Republic in 2006 to that in 2010?
Offer a terse response. 1.02. What is the ratio of the Total Labor Force (in %) of Israel in 2006 to that in 2010?
Offer a terse response. 0.98. What is the ratio of the Total Labor Force (in %) of Korea (Democratic) in 2006 to that in 2010?
Provide a succinct answer. 1.02. What is the ratio of the Total Labor Force (in %) in Dominican Republic in 2007 to that in 2008?
Your answer should be very brief. 1. What is the ratio of the Total Labor Force (in %) of Georgia in 2007 to that in 2008?
Provide a short and direct response. 1. What is the ratio of the Total Labor Force (in %) of Israel in 2007 to that in 2008?
Offer a terse response. 1. What is the ratio of the Total Labor Force (in %) in Korea (Democratic) in 2007 to that in 2008?
Offer a very short reply. 1. What is the ratio of the Total Labor Force (in %) in Dominican Republic in 2007 to that in 2009?
Keep it short and to the point. 1.01. What is the ratio of the Total Labor Force (in %) of Georgia in 2007 to that in 2009?
Keep it short and to the point. 0.99. What is the ratio of the Total Labor Force (in %) of Israel in 2007 to that in 2009?
Make the answer very short. 1. What is the ratio of the Total Labor Force (in %) of Korea (Democratic) in 2007 to that in 2009?
Provide a short and direct response. 1. What is the ratio of the Total Labor Force (in %) of Dominican Republic in 2007 to that in 2010?
Your answer should be compact. 1.02. What is the ratio of the Total Labor Force (in %) of Israel in 2007 to that in 2010?
Make the answer very short. 1. What is the ratio of the Total Labor Force (in %) in Korea (Democratic) in 2007 to that in 2010?
Keep it short and to the point. 1.01. What is the ratio of the Total Labor Force (in %) in Dominican Republic in 2008 to that in 2009?
Ensure brevity in your answer.  1. What is the ratio of the Total Labor Force (in %) in Georgia in 2008 to that in 2009?
Your answer should be compact. 0.99. What is the ratio of the Total Labor Force (in %) in Dominican Republic in 2008 to that in 2010?
Your answer should be very brief. 1.01. What is the ratio of the Total Labor Force (in %) in Georgia in 2008 to that in 2010?
Provide a short and direct response. 0.99. What is the ratio of the Total Labor Force (in %) in Dominican Republic in 2009 to that in 2010?
Keep it short and to the point. 1.01. What is the ratio of the Total Labor Force (in %) of Israel in 2009 to that in 2010?
Make the answer very short. 0.99. What is the difference between the highest and the second highest Total Labor Force (in %) in Dominican Republic?
Your answer should be compact. 0.1. What is the difference between the highest and the second highest Total Labor Force (in %) in Georgia?
Give a very brief answer. 0.9. What is the difference between the highest and the lowest Total Labor Force (in %) in Israel?
Provide a short and direct response. 2.3. What is the difference between the highest and the lowest Total Labor Force (in %) of Korea (Democratic)?
Make the answer very short. 2.8. 